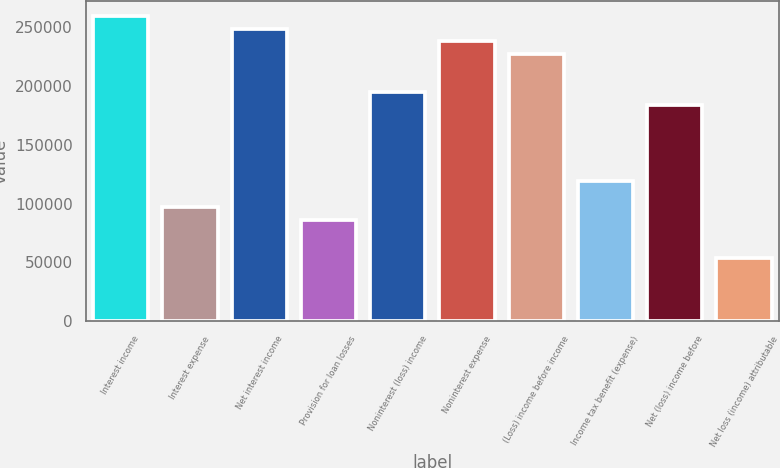Convert chart to OTSL. <chart><loc_0><loc_0><loc_500><loc_500><bar_chart><fcel>Interest income<fcel>Interest expense<fcel>Net interest income<fcel>Provision for loan losses<fcel>Noninterest (loss) income<fcel>Noninterest expense<fcel>(Loss) income before income<fcel>Income tax benefit (expense)<fcel>Net (loss) income before<fcel>Net loss (income) attributable<nl><fcel>259166<fcel>97187.5<fcel>248367<fcel>86388.9<fcel>194374<fcel>237568<fcel>226770<fcel>118785<fcel>183576<fcel>53993.3<nl></chart> 